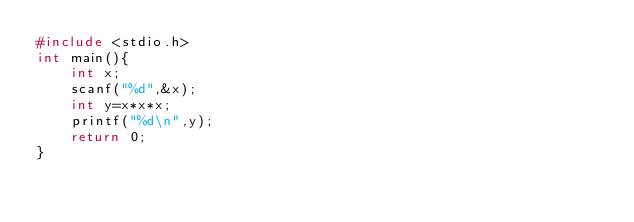<code> <loc_0><loc_0><loc_500><loc_500><_C_>#include <stdio.h>
int main(){
    int x;
    scanf("%d",&x);
    int y=x*x*x;
    printf("%d\n",y);
    return 0;
}
</code> 